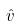Convert formula to latex. <formula><loc_0><loc_0><loc_500><loc_500>\hat { v }</formula> 